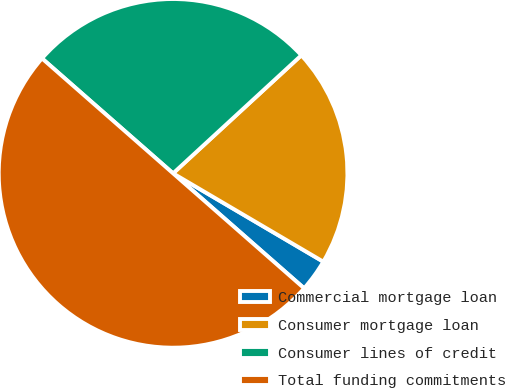<chart> <loc_0><loc_0><loc_500><loc_500><pie_chart><fcel>Commercial mortgage loan<fcel>Consumer mortgage loan<fcel>Consumer lines of credit<fcel>Total funding commitments<nl><fcel>3.0%<fcel>20.3%<fcel>26.7%<fcel>50.0%<nl></chart> 